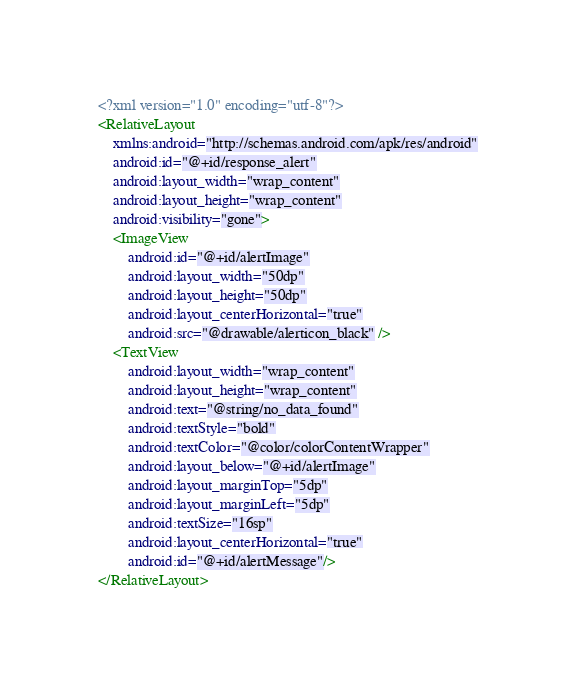<code> <loc_0><loc_0><loc_500><loc_500><_XML_><?xml version="1.0" encoding="utf-8"?>
<RelativeLayout
    xmlns:android="http://schemas.android.com/apk/res/android"
    android:id="@+id/response_alert"
    android:layout_width="wrap_content"
    android:layout_height="wrap_content"
    android:visibility="gone">
    <ImageView
        android:id="@+id/alertImage"
        android:layout_width="50dp"
        android:layout_height="50dp"
        android:layout_centerHorizontal="true"
        android:src="@drawable/alerticon_black" />
    <TextView
        android:layout_width="wrap_content"
        android:layout_height="wrap_content"
        android:text="@string/no_data_found"
        android:textStyle="bold"
        android:textColor="@color/colorContentWrapper"
        android:layout_below="@+id/alertImage"
        android:layout_marginTop="5dp"
        android:layout_marginLeft="5dp"
        android:textSize="16sp"
        android:layout_centerHorizontal="true"
        android:id="@+id/alertMessage"/>
</RelativeLayout></code> 